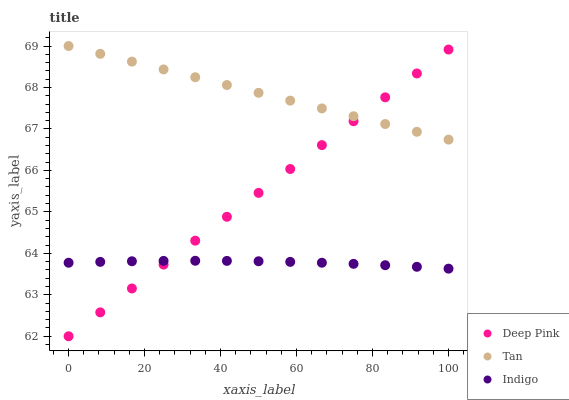Does Indigo have the minimum area under the curve?
Answer yes or no. Yes. Does Tan have the maximum area under the curve?
Answer yes or no. Yes. Does Deep Pink have the minimum area under the curve?
Answer yes or no. No. Does Deep Pink have the maximum area under the curve?
Answer yes or no. No. Is Deep Pink the smoothest?
Answer yes or no. Yes. Is Indigo the roughest?
Answer yes or no. Yes. Is Indigo the smoothest?
Answer yes or no. No. Is Deep Pink the roughest?
Answer yes or no. No. Does Deep Pink have the lowest value?
Answer yes or no. Yes. Does Indigo have the lowest value?
Answer yes or no. No. Does Tan have the highest value?
Answer yes or no. Yes. Does Deep Pink have the highest value?
Answer yes or no. No. Is Indigo less than Tan?
Answer yes or no. Yes. Is Tan greater than Indigo?
Answer yes or no. Yes. Does Tan intersect Deep Pink?
Answer yes or no. Yes. Is Tan less than Deep Pink?
Answer yes or no. No. Is Tan greater than Deep Pink?
Answer yes or no. No. Does Indigo intersect Tan?
Answer yes or no. No. 